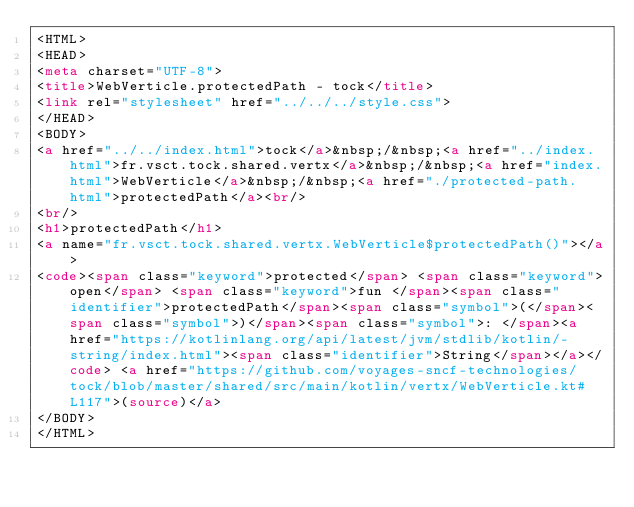<code> <loc_0><loc_0><loc_500><loc_500><_HTML_><HTML>
<HEAD>
<meta charset="UTF-8">
<title>WebVerticle.protectedPath - tock</title>
<link rel="stylesheet" href="../../../style.css">
</HEAD>
<BODY>
<a href="../../index.html">tock</a>&nbsp;/&nbsp;<a href="../index.html">fr.vsct.tock.shared.vertx</a>&nbsp;/&nbsp;<a href="index.html">WebVerticle</a>&nbsp;/&nbsp;<a href="./protected-path.html">protectedPath</a><br/>
<br/>
<h1>protectedPath</h1>
<a name="fr.vsct.tock.shared.vertx.WebVerticle$protectedPath()"></a>
<code><span class="keyword">protected</span> <span class="keyword">open</span> <span class="keyword">fun </span><span class="identifier">protectedPath</span><span class="symbol">(</span><span class="symbol">)</span><span class="symbol">: </span><a href="https://kotlinlang.org/api/latest/jvm/stdlib/kotlin/-string/index.html"><span class="identifier">String</span></a></code> <a href="https://github.com/voyages-sncf-technologies/tock/blob/master/shared/src/main/kotlin/vertx/WebVerticle.kt#L117">(source)</a>
</BODY>
</HTML>
</code> 